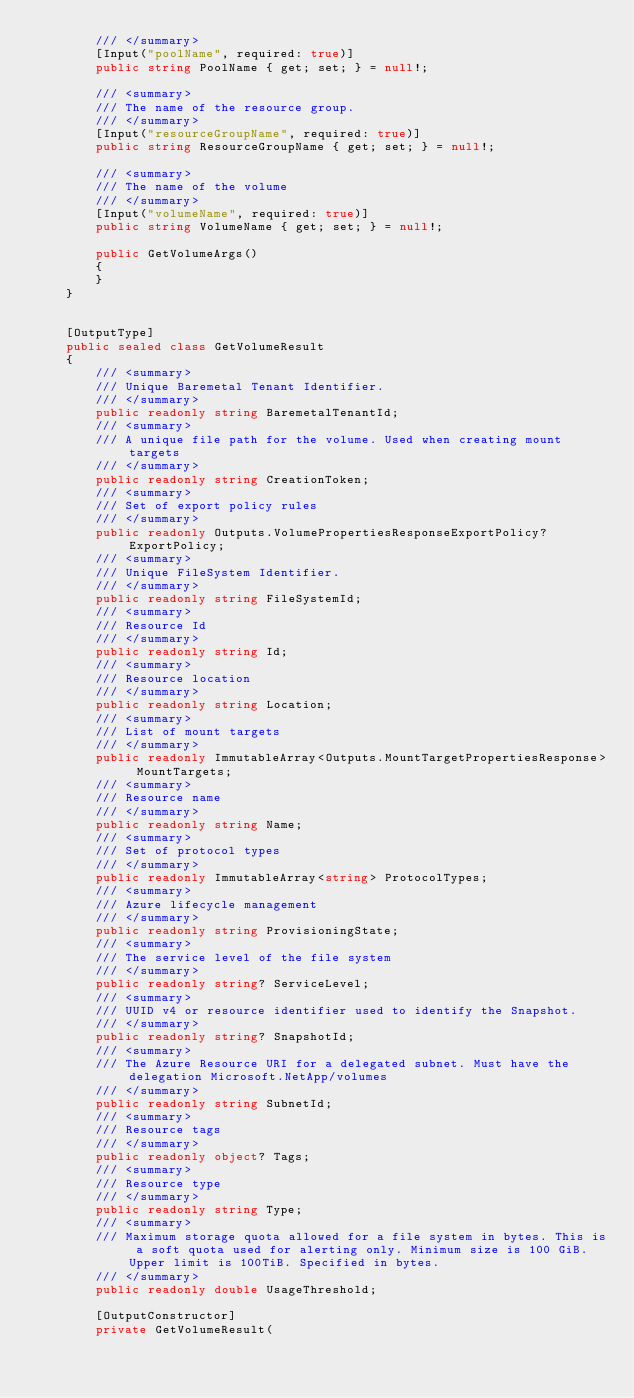Convert code to text. <code><loc_0><loc_0><loc_500><loc_500><_C#_>        /// </summary>
        [Input("poolName", required: true)]
        public string PoolName { get; set; } = null!;

        /// <summary>
        /// The name of the resource group.
        /// </summary>
        [Input("resourceGroupName", required: true)]
        public string ResourceGroupName { get; set; } = null!;

        /// <summary>
        /// The name of the volume
        /// </summary>
        [Input("volumeName", required: true)]
        public string VolumeName { get; set; } = null!;

        public GetVolumeArgs()
        {
        }
    }


    [OutputType]
    public sealed class GetVolumeResult
    {
        /// <summary>
        /// Unique Baremetal Tenant Identifier.
        /// </summary>
        public readonly string BaremetalTenantId;
        /// <summary>
        /// A unique file path for the volume. Used when creating mount targets
        /// </summary>
        public readonly string CreationToken;
        /// <summary>
        /// Set of export policy rules
        /// </summary>
        public readonly Outputs.VolumePropertiesResponseExportPolicy? ExportPolicy;
        /// <summary>
        /// Unique FileSystem Identifier.
        /// </summary>
        public readonly string FileSystemId;
        /// <summary>
        /// Resource Id
        /// </summary>
        public readonly string Id;
        /// <summary>
        /// Resource location
        /// </summary>
        public readonly string Location;
        /// <summary>
        /// List of mount targets
        /// </summary>
        public readonly ImmutableArray<Outputs.MountTargetPropertiesResponse> MountTargets;
        /// <summary>
        /// Resource name
        /// </summary>
        public readonly string Name;
        /// <summary>
        /// Set of protocol types
        /// </summary>
        public readonly ImmutableArray<string> ProtocolTypes;
        /// <summary>
        /// Azure lifecycle management
        /// </summary>
        public readonly string ProvisioningState;
        /// <summary>
        /// The service level of the file system
        /// </summary>
        public readonly string? ServiceLevel;
        /// <summary>
        /// UUID v4 or resource identifier used to identify the Snapshot.
        /// </summary>
        public readonly string? SnapshotId;
        /// <summary>
        /// The Azure Resource URI for a delegated subnet. Must have the delegation Microsoft.NetApp/volumes
        /// </summary>
        public readonly string SubnetId;
        /// <summary>
        /// Resource tags
        /// </summary>
        public readonly object? Tags;
        /// <summary>
        /// Resource type
        /// </summary>
        public readonly string Type;
        /// <summary>
        /// Maximum storage quota allowed for a file system in bytes. This is a soft quota used for alerting only. Minimum size is 100 GiB. Upper limit is 100TiB. Specified in bytes.
        /// </summary>
        public readonly double UsageThreshold;

        [OutputConstructor]
        private GetVolumeResult(</code> 